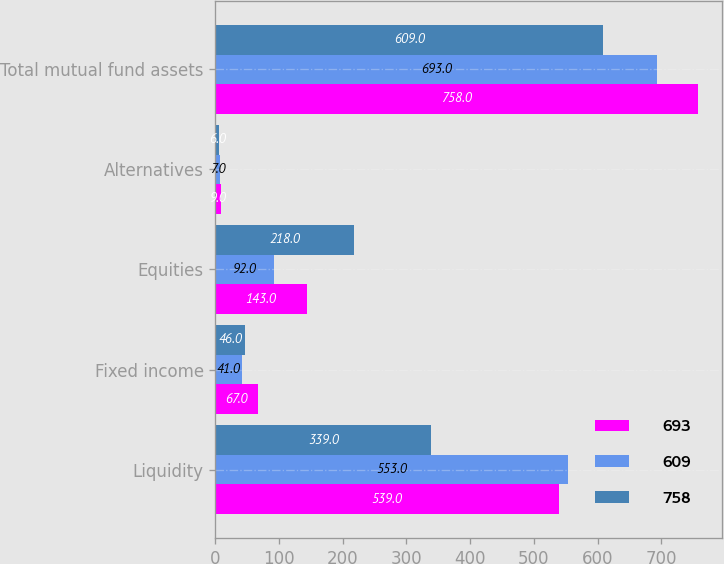Convert chart to OTSL. <chart><loc_0><loc_0><loc_500><loc_500><stacked_bar_chart><ecel><fcel>Liquidity<fcel>Fixed income<fcel>Equities<fcel>Alternatives<fcel>Total mutual fund assets<nl><fcel>693<fcel>539<fcel>67<fcel>143<fcel>9<fcel>758<nl><fcel>609<fcel>553<fcel>41<fcel>92<fcel>7<fcel>693<nl><fcel>758<fcel>339<fcel>46<fcel>218<fcel>6<fcel>609<nl></chart> 